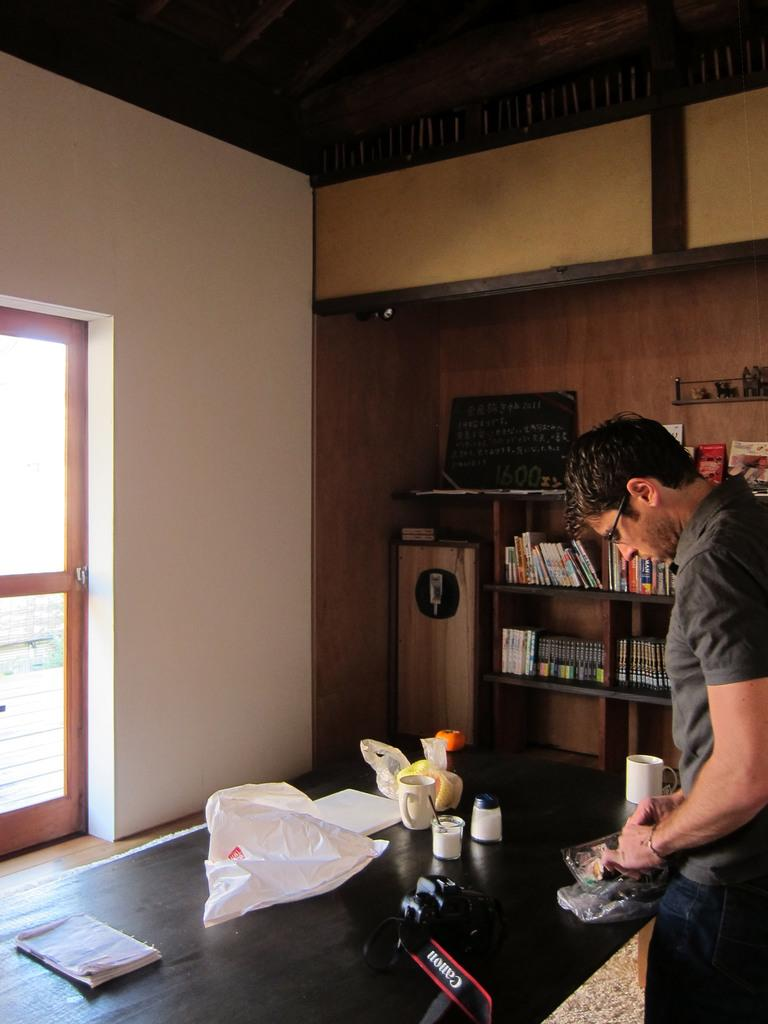<image>
Share a concise interpretation of the image provided. a man standing at a counter next to a canon camera 